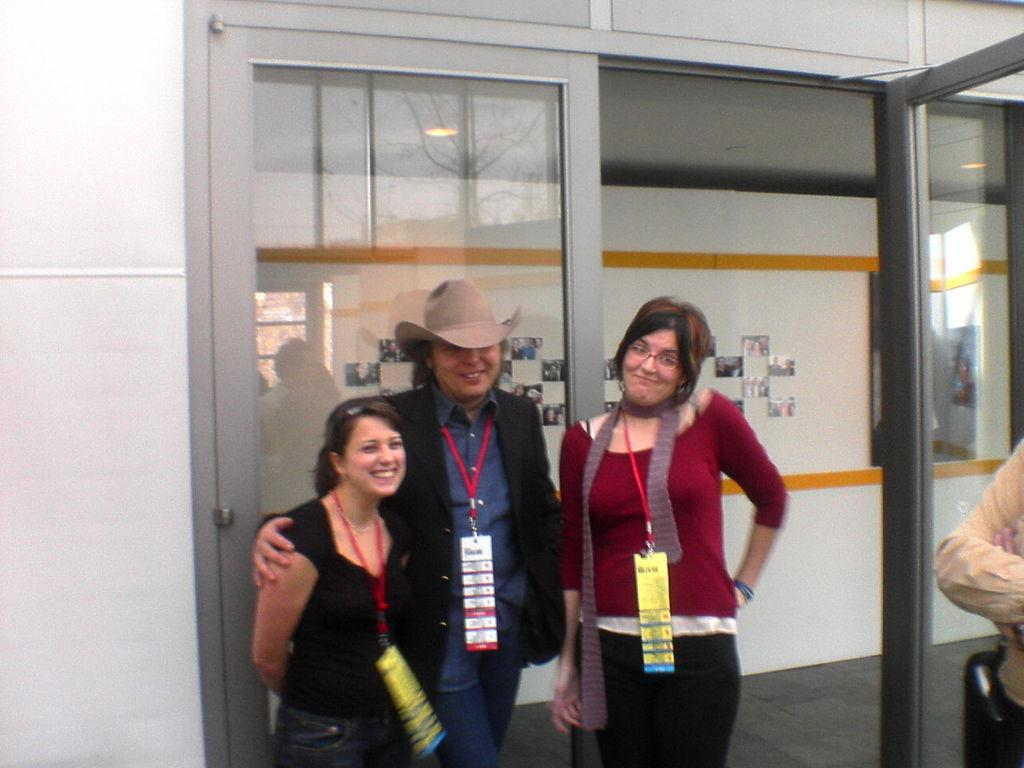What is happening in the image? There are people standing in the image. What can be seen in the background of the image? There is a wall in the background of the image. Are there any openings in the wall? Yes, there are doors in the wall. What type of cork can be seen on the wall in the image? There is no cork present on the wall in the image. 